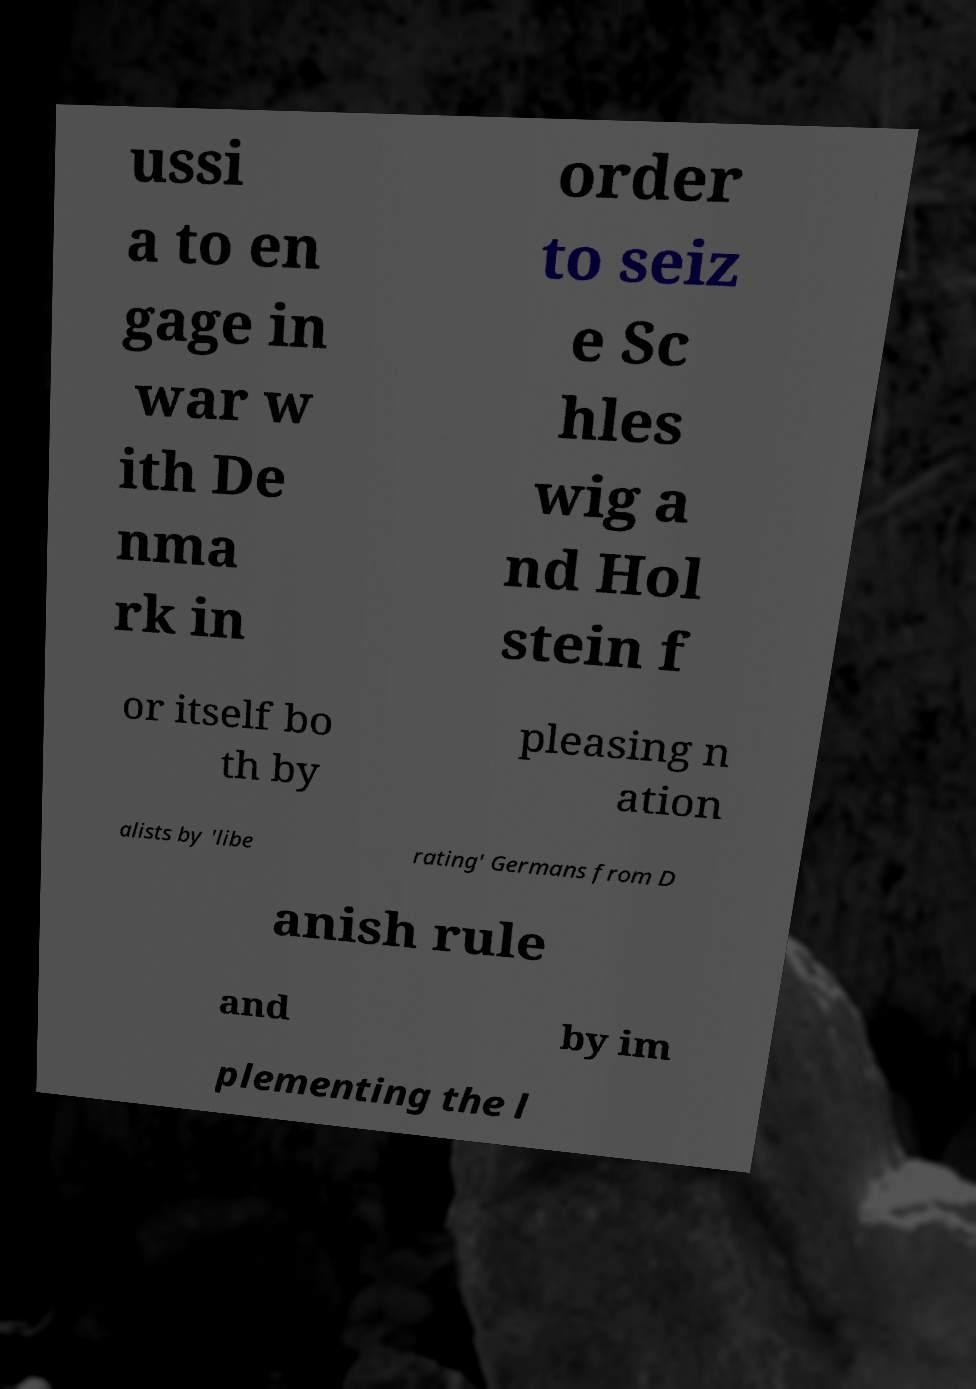Can you read and provide the text displayed in the image?This photo seems to have some interesting text. Can you extract and type it out for me? ussi a to en gage in war w ith De nma rk in order to seiz e Sc hles wig a nd Hol stein f or itself bo th by pleasing n ation alists by 'libe rating' Germans from D anish rule and by im plementing the l 